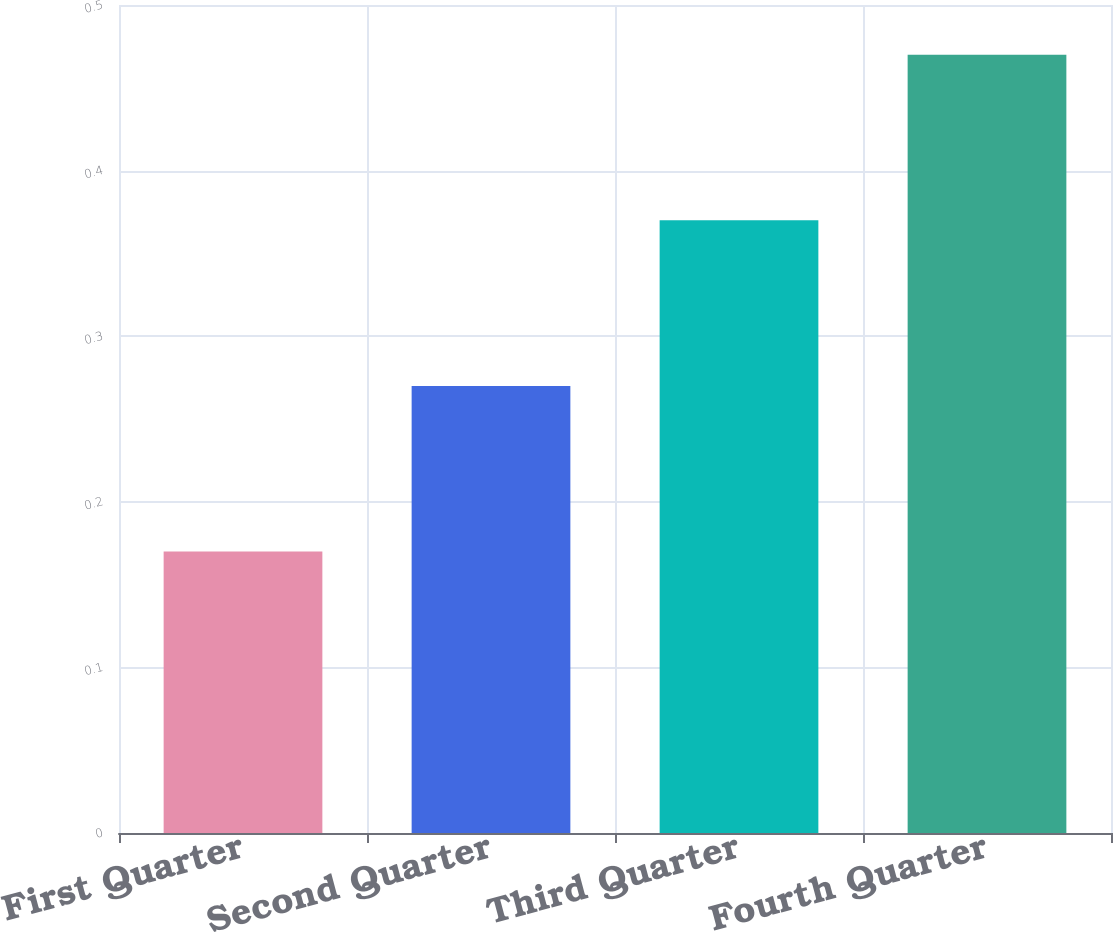Convert chart to OTSL. <chart><loc_0><loc_0><loc_500><loc_500><bar_chart><fcel>First Quarter<fcel>Second Quarter<fcel>Third Quarter<fcel>Fourth Quarter<nl><fcel>0.17<fcel>0.27<fcel>0.37<fcel>0.47<nl></chart> 